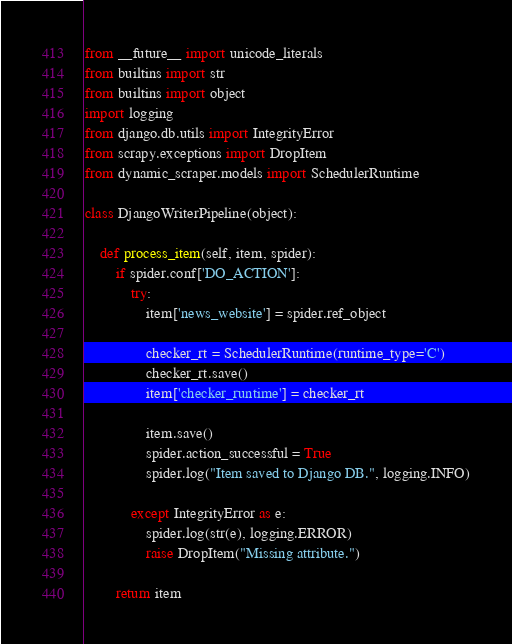<code> <loc_0><loc_0><loc_500><loc_500><_Python_>from __future__ import unicode_literals
from builtins import str
from builtins import object
import logging
from django.db.utils import IntegrityError
from scrapy.exceptions import DropItem
from dynamic_scraper.models import SchedulerRuntime

class DjangoWriterPipeline(object):
    
    def process_item(self, item, spider):
        if spider.conf['DO_ACTION']:
            try:
                item['news_website'] = spider.ref_object
                
                checker_rt = SchedulerRuntime(runtime_type='C')
                checker_rt.save()
                item['checker_runtime'] = checker_rt
                
                item.save()
                spider.action_successful = True
                spider.log("Item saved to Django DB.", logging.INFO)
                    
            except IntegrityError as e:
                spider.log(str(e), logging.ERROR)
                raise DropItem("Missing attribute.")
                
        return item</code> 